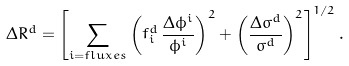<formula> <loc_0><loc_0><loc_500><loc_500>\Delta R ^ { d } = \left [ \sum _ { i = { f l u x e s } } \left ( f _ { i } ^ { d } \, \frac { \Delta \phi ^ { i } } { \phi ^ { i } } \right ) ^ { 2 } + \left ( \frac { \Delta \sigma ^ { d } } { \sigma ^ { d } } \right ) ^ { 2 } \right ] ^ { 1 / 2 } .</formula> 